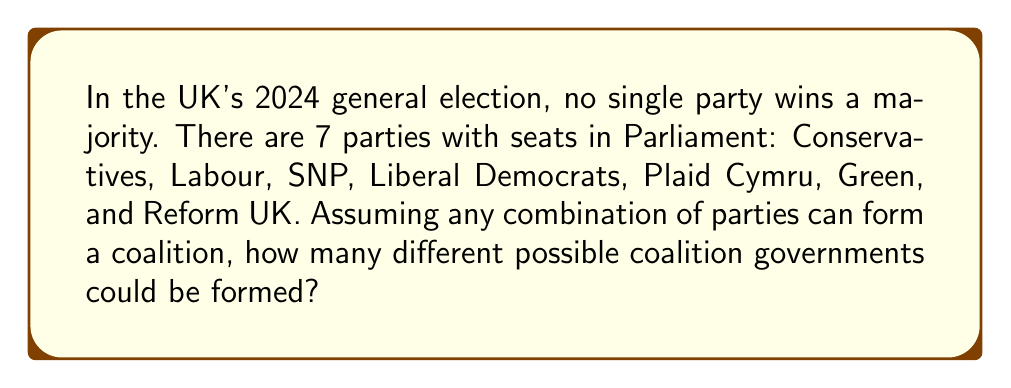Can you answer this question? Let's approach this step-by-step:

1) This is a combination problem. We need to find the total number of possible combinations of parties, excluding the empty set (as a coalition must include at least one party).

2) For each party, we have two choices: it's either in the coalition or not. This suggests we can use the power set concept.

3) The number of elements in a power set of n elements is $2^n$.

4) However, we need to exclude the empty set (where no party is in the coalition).

5) Therefore, the formula for our solution is:

   $$ \text{Number of possible coalitions} = 2^n - 1 $$

   Where n is the number of parties.

6) In this case, n = 7 (Conservatives, Labour, SNP, Liberal Democrats, Plaid Cymru, Green, and Reform UK).

7) Plugging this into our formula:

   $$ \text{Number of possible coalitions} = 2^7 - 1 $$

8) Calculate:
   $$ 2^7 = 128 $$
   $$ 128 - 1 = 127 $$

Therefore, there are 127 possible coalition governments that could be formed.
Answer: 127 